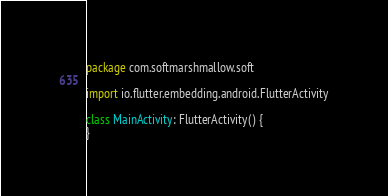<code> <loc_0><loc_0><loc_500><loc_500><_Kotlin_>package com.softmarshmallow.soft

import io.flutter.embedding.android.FlutterActivity

class MainActivity: FlutterActivity() {
}
</code> 